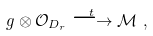<formula> <loc_0><loc_0><loc_500><loc_500>\ g \otimes { \mathcal { O } } _ { D _ { r } } \overset { t } { \longrightarrow } { \mathcal { M } } \ ,</formula> 